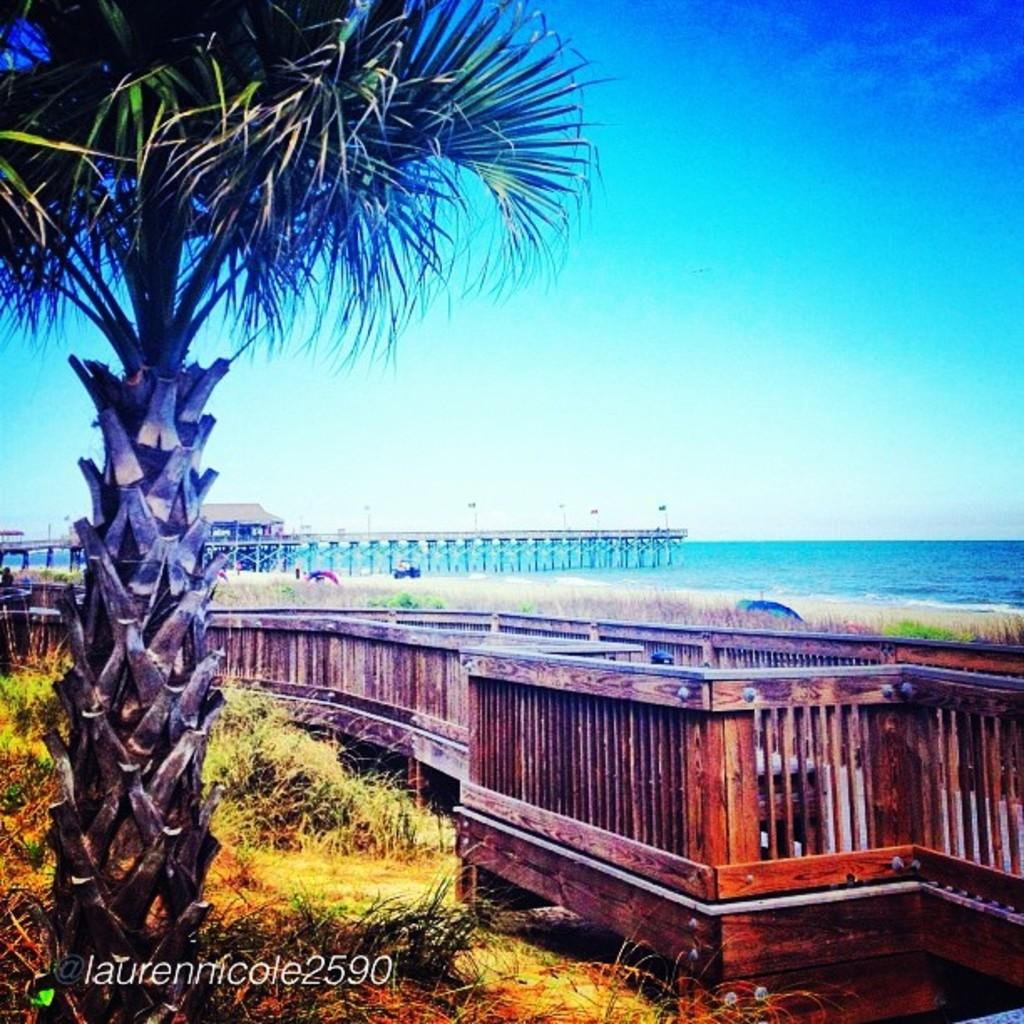What type of vegetation is present in the image? There is a tree and grass in the image. What type of structure can be seen in the image? There is a bridge and a shed in the image. What type of fencing is present in the image? There is wooden fencing in the image. What type of surface can be seen in the image? There is water visible in the image. What is the color of the sky in the image? The sky is blue and white in color. What type of grain is being harvested in the image? There is no grain present in the image. How many turkeys can be seen in the image? There are no turkeys present in the image. 